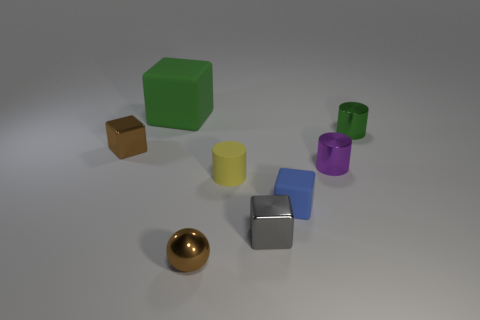What might be the purpose of these objects in the image? These objects seem to be a collection of geometric shapes that could be used for educational purposes, such as teaching about geometry, volume, and spatial awareness. Alternatively, they might also be part of a visual or artistic display meant to showcase material properties and the interplay of light and shadow on different surfaces. Are any of these objects capable of movement on their own? From the image alone, there's no indication that any of the objects are capable of self-movement. They all appear to be inanimate and would require an external force, such as a person or a machine, to move them. 